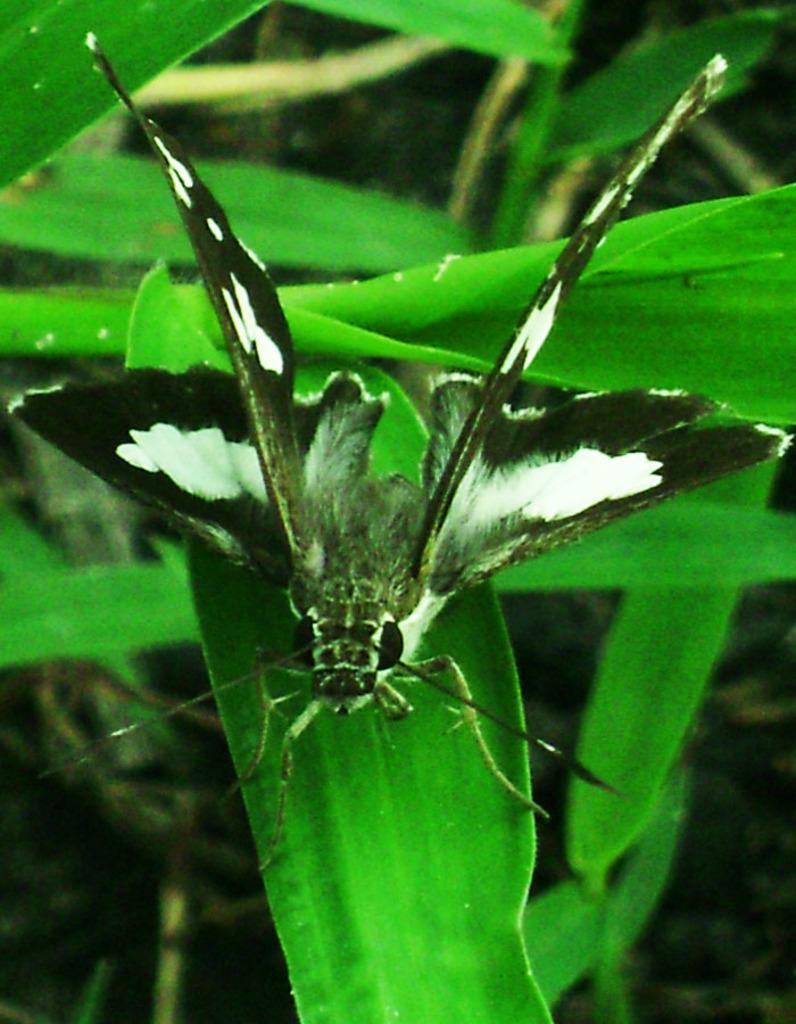How would you summarize this image in a sentence or two? In this image we can see an insect on the leaf and in the background we can see some leaves. 